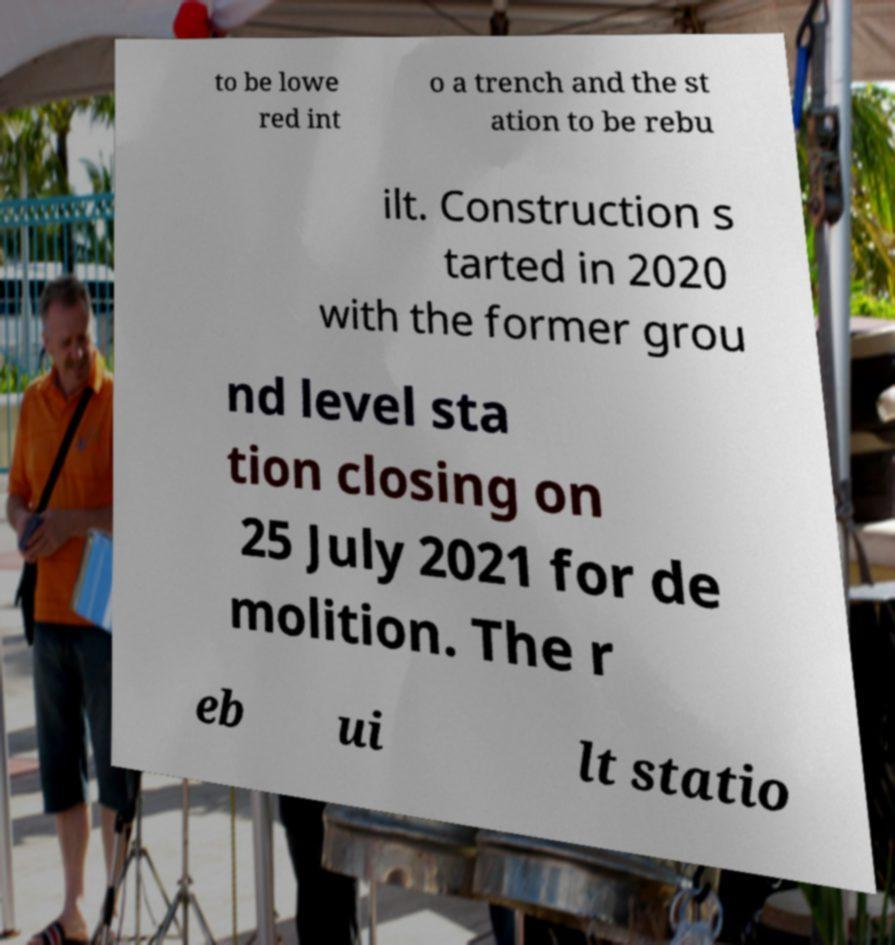Can you accurately transcribe the text from the provided image for me? to be lowe red int o a trench and the st ation to be rebu ilt. Construction s tarted in 2020 with the former grou nd level sta tion closing on 25 July 2021 for de molition. The r eb ui lt statio 